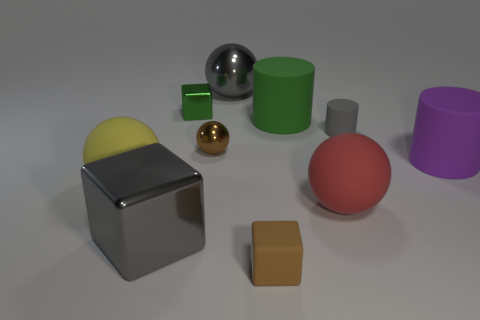Subtract all cubes. How many objects are left? 7 Subtract all large green cubes. Subtract all big purple things. How many objects are left? 9 Add 1 big blocks. How many big blocks are left? 2 Add 2 brown blocks. How many brown blocks exist? 3 Subtract 0 yellow cylinders. How many objects are left? 10 